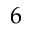Convert formula to latex. <formula><loc_0><loc_0><loc_500><loc_500>6</formula> 